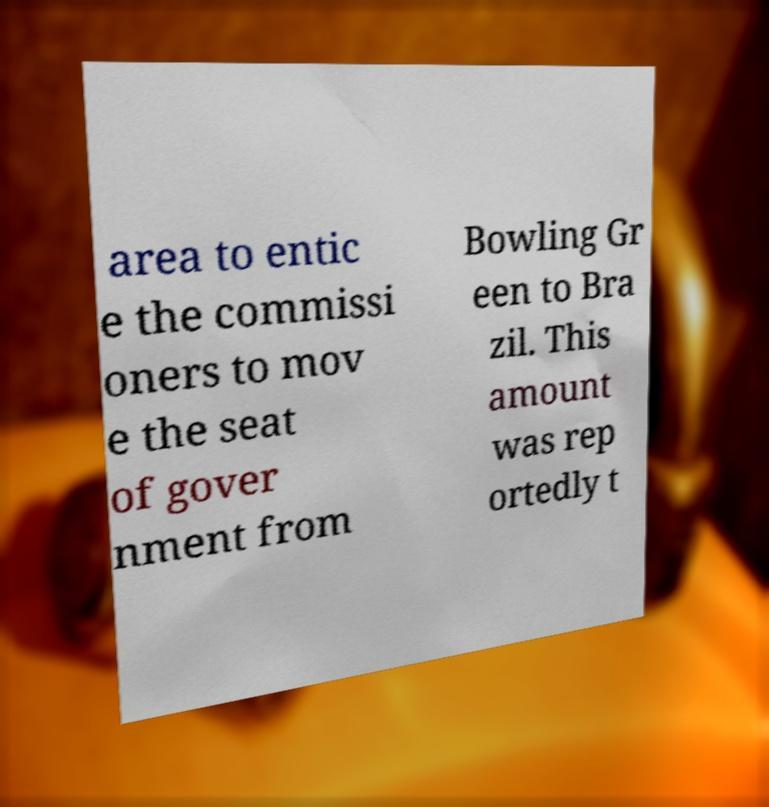Can you read and provide the text displayed in the image?This photo seems to have some interesting text. Can you extract and type it out for me? area to entic e the commissi oners to mov e the seat of gover nment from Bowling Gr een to Bra zil. This amount was rep ortedly t 